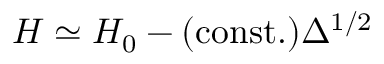Convert formula to latex. <formula><loc_0><loc_0><loc_500><loc_500>H \simeq H _ { 0 } - ( c o n s t . ) \Delta ^ { 1 / 2 }</formula> 